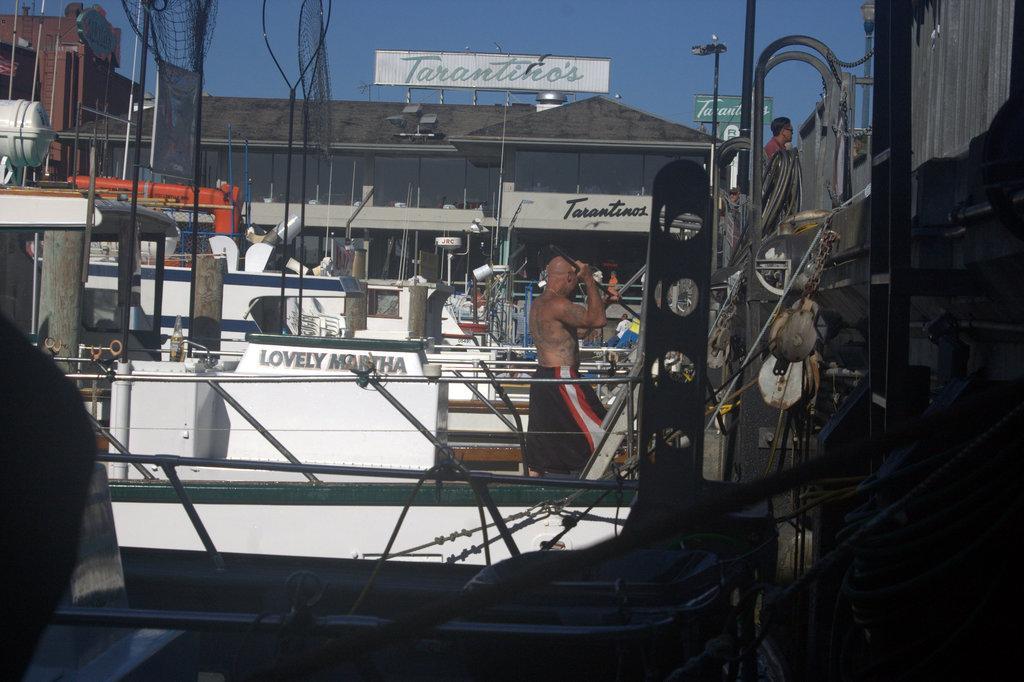Please provide a concise description of this image. In the image there is a man with no shirt walking in a boat, this seems to be shipyard, there are many boats in the background followed by a building above it and above its sky. 